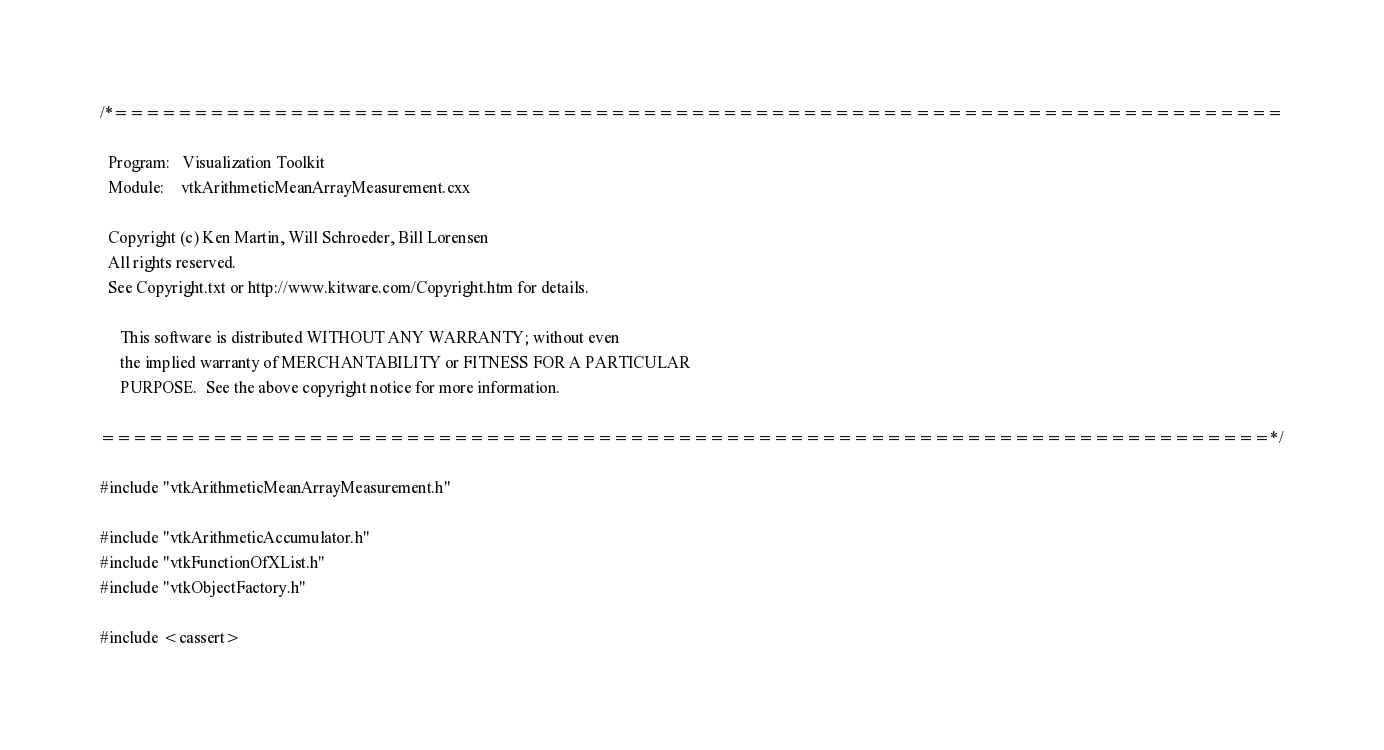<code> <loc_0><loc_0><loc_500><loc_500><_C++_>/*=========================================================================

  Program:   Visualization Toolkit
  Module:    vtkArithmeticMeanArrayMeasurement.cxx

  Copyright (c) Ken Martin, Will Schroeder, Bill Lorensen
  All rights reserved.
  See Copyright.txt or http://www.kitware.com/Copyright.htm for details.

     This software is distributed WITHOUT ANY WARRANTY; without even
     the implied warranty of MERCHANTABILITY or FITNESS FOR A PARTICULAR
     PURPOSE.  See the above copyright notice for more information.

=========================================================================*/

#include "vtkArithmeticMeanArrayMeasurement.h"

#include "vtkArithmeticAccumulator.h"
#include "vtkFunctionOfXList.h"
#include "vtkObjectFactory.h"

#include <cassert>
</code> 